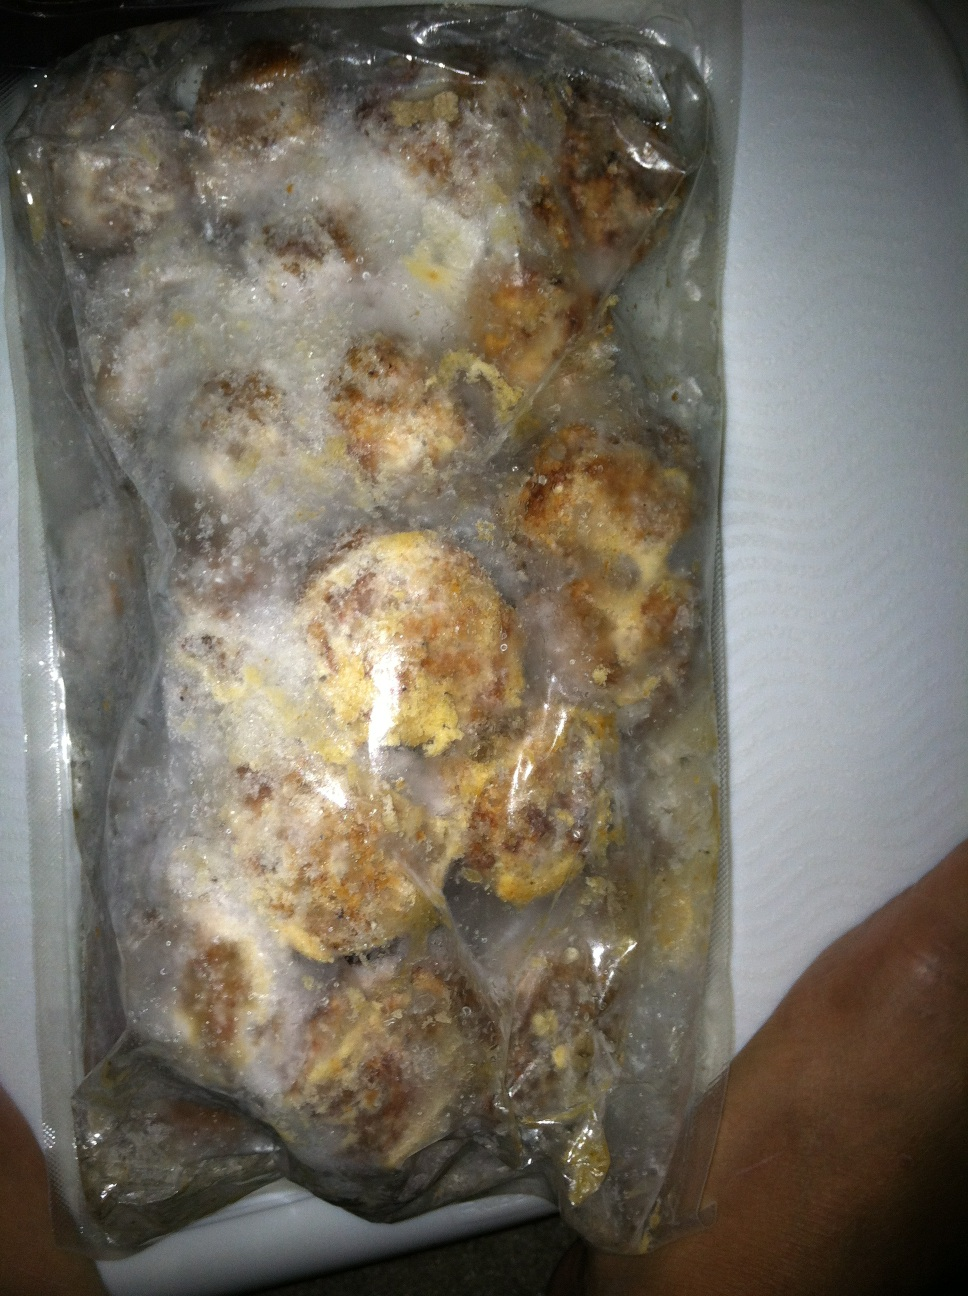How might one quickly prepare a meal using this package? To quickly prepare a meal using this package of frozen meatballs, you could heat them in the microwave or oven until they are thoroughly warmed. Serve them with a marinara sauce over spaghetti, or make meatball subs with some bread, cheese, and marinara sauce. Additionally, you could add them to a soup for a hearty meal. 